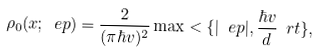Convert formula to latex. <formula><loc_0><loc_0><loc_500><loc_500>\rho _ { 0 } ( x ; \ e p ) = \frac { 2 } { ( \pi \hbar { v } ) ^ { 2 } } \max < \{ | \ e p | , \frac { \hbar { v } } { d } \ r t \} ,</formula> 